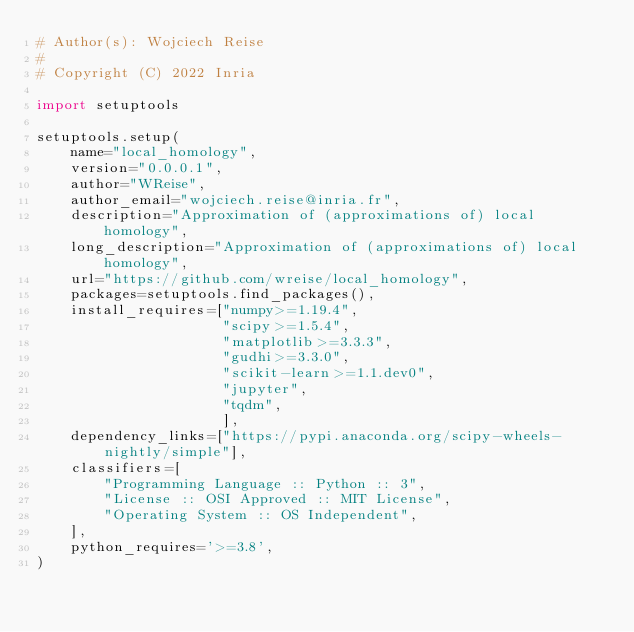<code> <loc_0><loc_0><loc_500><loc_500><_Python_># Author(s): Wojciech Reise
#
# Copyright (C) 2022 Inria

import setuptools

setuptools.setup(
    name="local_homology",
    version="0.0.0.1",
    author="WReise",
    author_email="wojciech.reise@inria.fr",
    description="Approximation of (approximations of) local homology",
    long_description="Approximation of (approximations of) local homology",
    url="https://github.com/wreise/local_homology",
    packages=setuptools.find_packages(),
    install_requires=["numpy>=1.19.4",
                      "scipy>=1.5.4",
                      "matplotlib>=3.3.3",
                      "gudhi>=3.3.0",
                      "scikit-learn>=1.1.dev0",
                      "jupyter",
                      "tqdm",
                      ],
    dependency_links=["https://pypi.anaconda.org/scipy-wheels-nightly/simple"],
    classifiers=[
        "Programming Language :: Python :: 3",
        "License :: OSI Approved :: MIT License",
        "Operating System :: OS Independent",
    ],
    python_requires='>=3.8',
)
</code> 